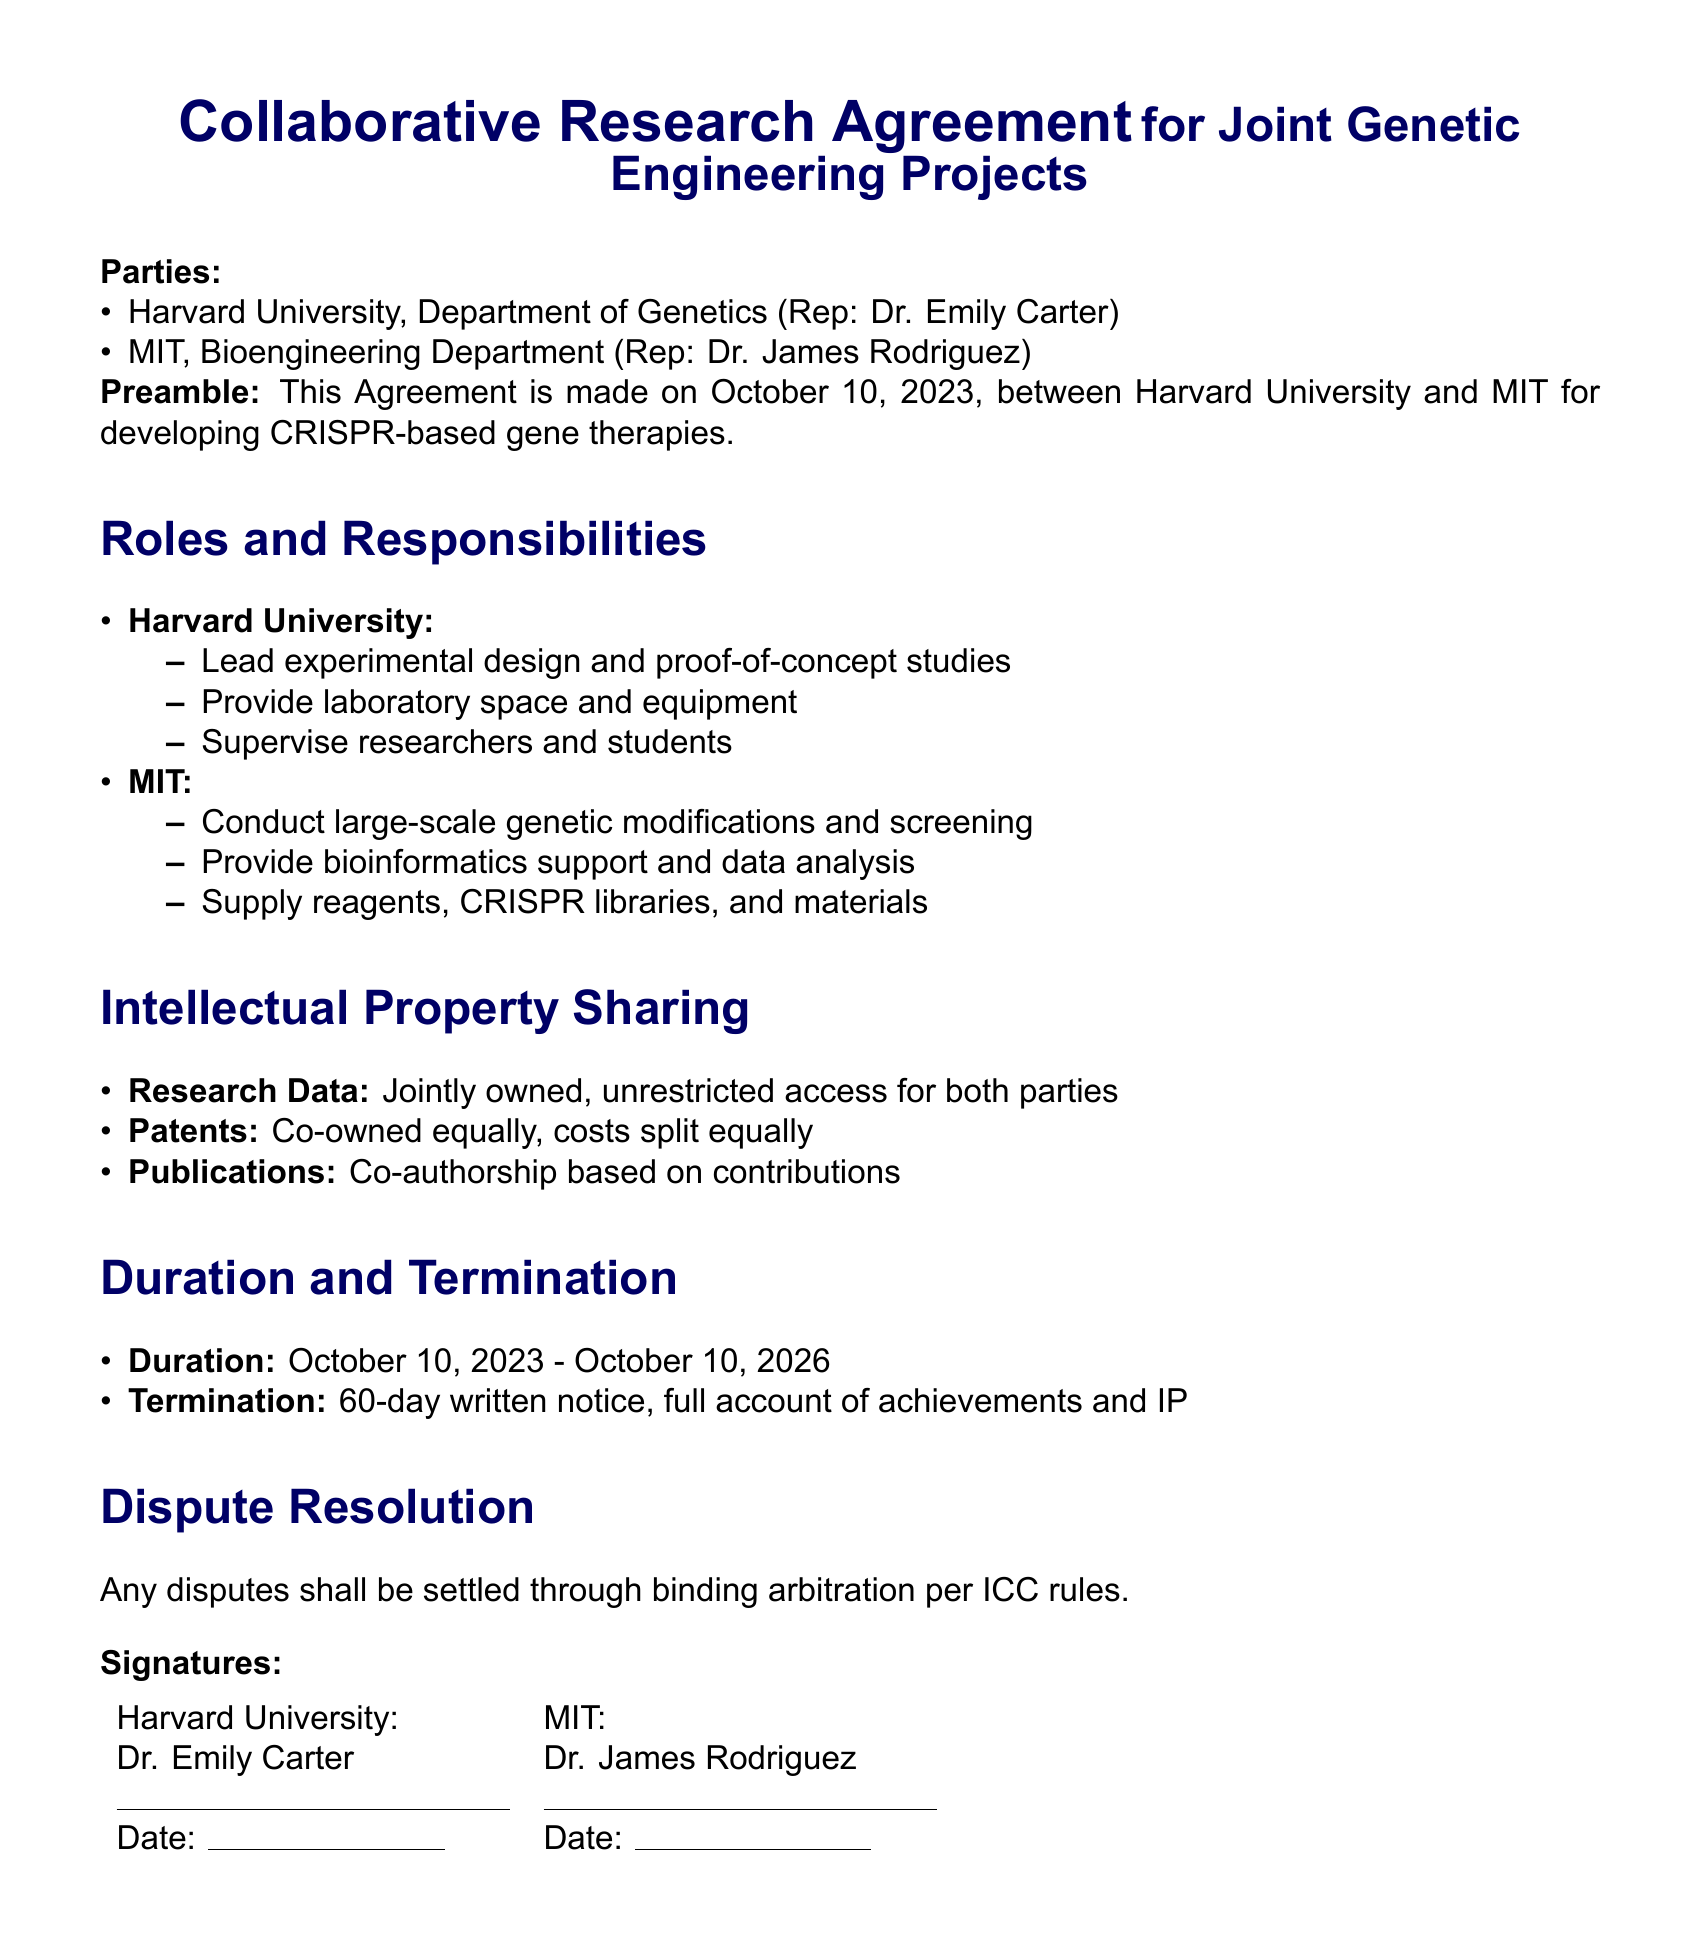What is the duration of the agreement? The duration of the agreement is specified in the document, which states it lasts from October 10, 2023, to October 10, 2026.
Answer: October 10, 2023 - October 10, 2026 Who represents Harvard University? The document lists Dr. Emily Carter as the representative for Harvard University.
Answer: Dr. Emily Carter What is the main focus of the research agreement? The preamble of the document explicitly mentions that the agreement is for developing CRISPR-based gene therapies.
Answer: CRISPR-based gene therapies What is the termination notice period? The document specifies that a written notice of 60 days is required for termination.
Answer: 60 days How are the research data treated? The document states that research data is jointly owned with unrestricted access for both parties.
Answer: Jointly owned, unrestricted access What responsibilities does MIT have? The document outlines specific responsibilities for MIT, including conducting large-scale genetic modifications and providing bioinformatics support.
Answer: Conduct large-scale genetic modifications and screening How are patents shared according to the agreement? The document clarifies that patents are co-owned equally, with costs split equally as well.
Answer: Co-owned equally, costs split equally What type of resolution is suggested for disputes? The document specifies that any disputes shall be resolved through binding arbitration per ICC rules.
Answer: Binding arbitration per ICC rules What type of collaborations does this agreement pertain to? The focus of the agreement is specifically on joint genetic engineering projects.
Answer: Joint genetic engineering projects 